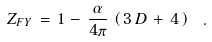Convert formula to latex. <formula><loc_0><loc_0><loc_500><loc_500>Z _ { F Y } \, = \, 1 \, - \, \frac { \alpha } { 4 \pi } \, \left ( \, 3 \, D \, + \, 4 \, \right ) \ .</formula> 